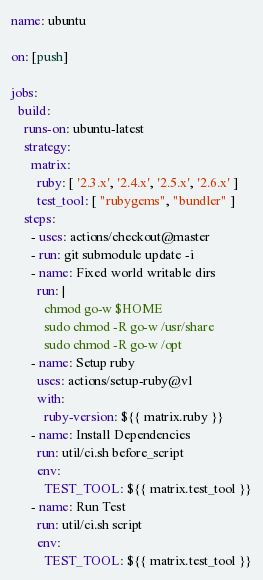Convert code to text. <code><loc_0><loc_0><loc_500><loc_500><_YAML_>name: ubuntu

on: [push]

jobs:
  build:
    runs-on: ubuntu-latest
    strategy:
      matrix:
        ruby: [ '2.3.x', '2.4.x', '2.5.x', '2.6.x' ]
        test_tool: [ "rubygems", "bundler" ]
    steps:
      - uses: actions/checkout@master
      - run: git submodule update -i
      - name: Fixed world writable dirs
        run: |
          chmod go-w $HOME
          sudo chmod -R go-w /usr/share
          sudo chmod -R go-w /opt
      - name: Setup ruby
        uses: actions/setup-ruby@v1
        with:
          ruby-version: ${{ matrix.ruby }}
      - name: Install Dependencies
        run: util/ci.sh before_script
        env:
          TEST_TOOL: ${{ matrix.test_tool }}
      - name: Run Test
        run: util/ci.sh script
        env:
          TEST_TOOL: ${{ matrix.test_tool }}
</code> 